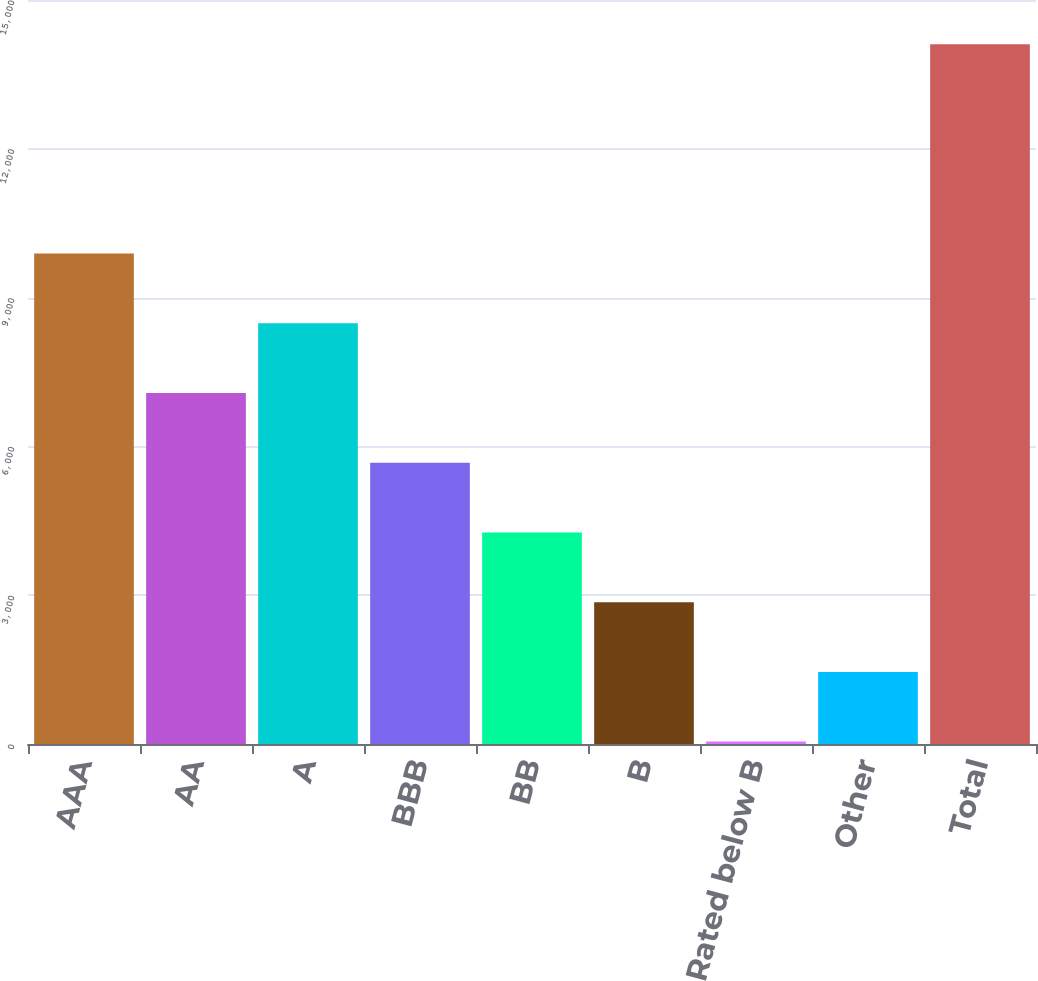<chart> <loc_0><loc_0><loc_500><loc_500><bar_chart><fcel>AAA<fcel>AA<fcel>A<fcel>BBB<fcel>BB<fcel>B<fcel>Rated below B<fcel>Other<fcel>Total<nl><fcel>9889.58<fcel>7077.7<fcel>8483.64<fcel>5671.76<fcel>4265.82<fcel>2859.88<fcel>48<fcel>1453.94<fcel>14107.4<nl></chart> 